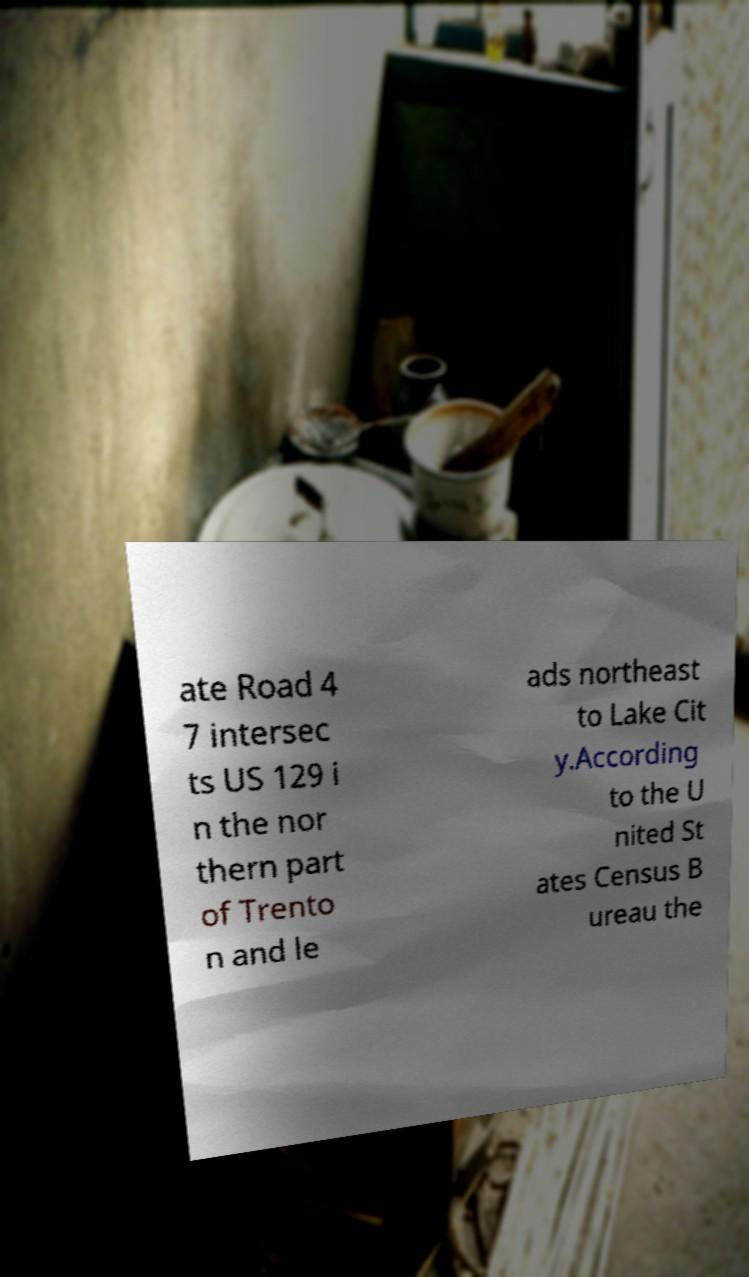Can you accurately transcribe the text from the provided image for me? ate Road 4 7 intersec ts US 129 i n the nor thern part of Trento n and le ads northeast to Lake Cit y.According to the U nited St ates Census B ureau the 